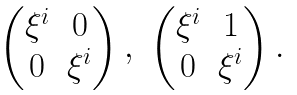Convert formula to latex. <formula><loc_0><loc_0><loc_500><loc_500>\begin{matrix} \begin{pmatrix} \xi ^ { i } & 0 \\ 0 & \xi ^ { i } \end{pmatrix} , & \begin{pmatrix} \xi ^ { i } & 1 \\ 0 & \xi ^ { i } \end{pmatrix} . & \end{matrix}</formula> 